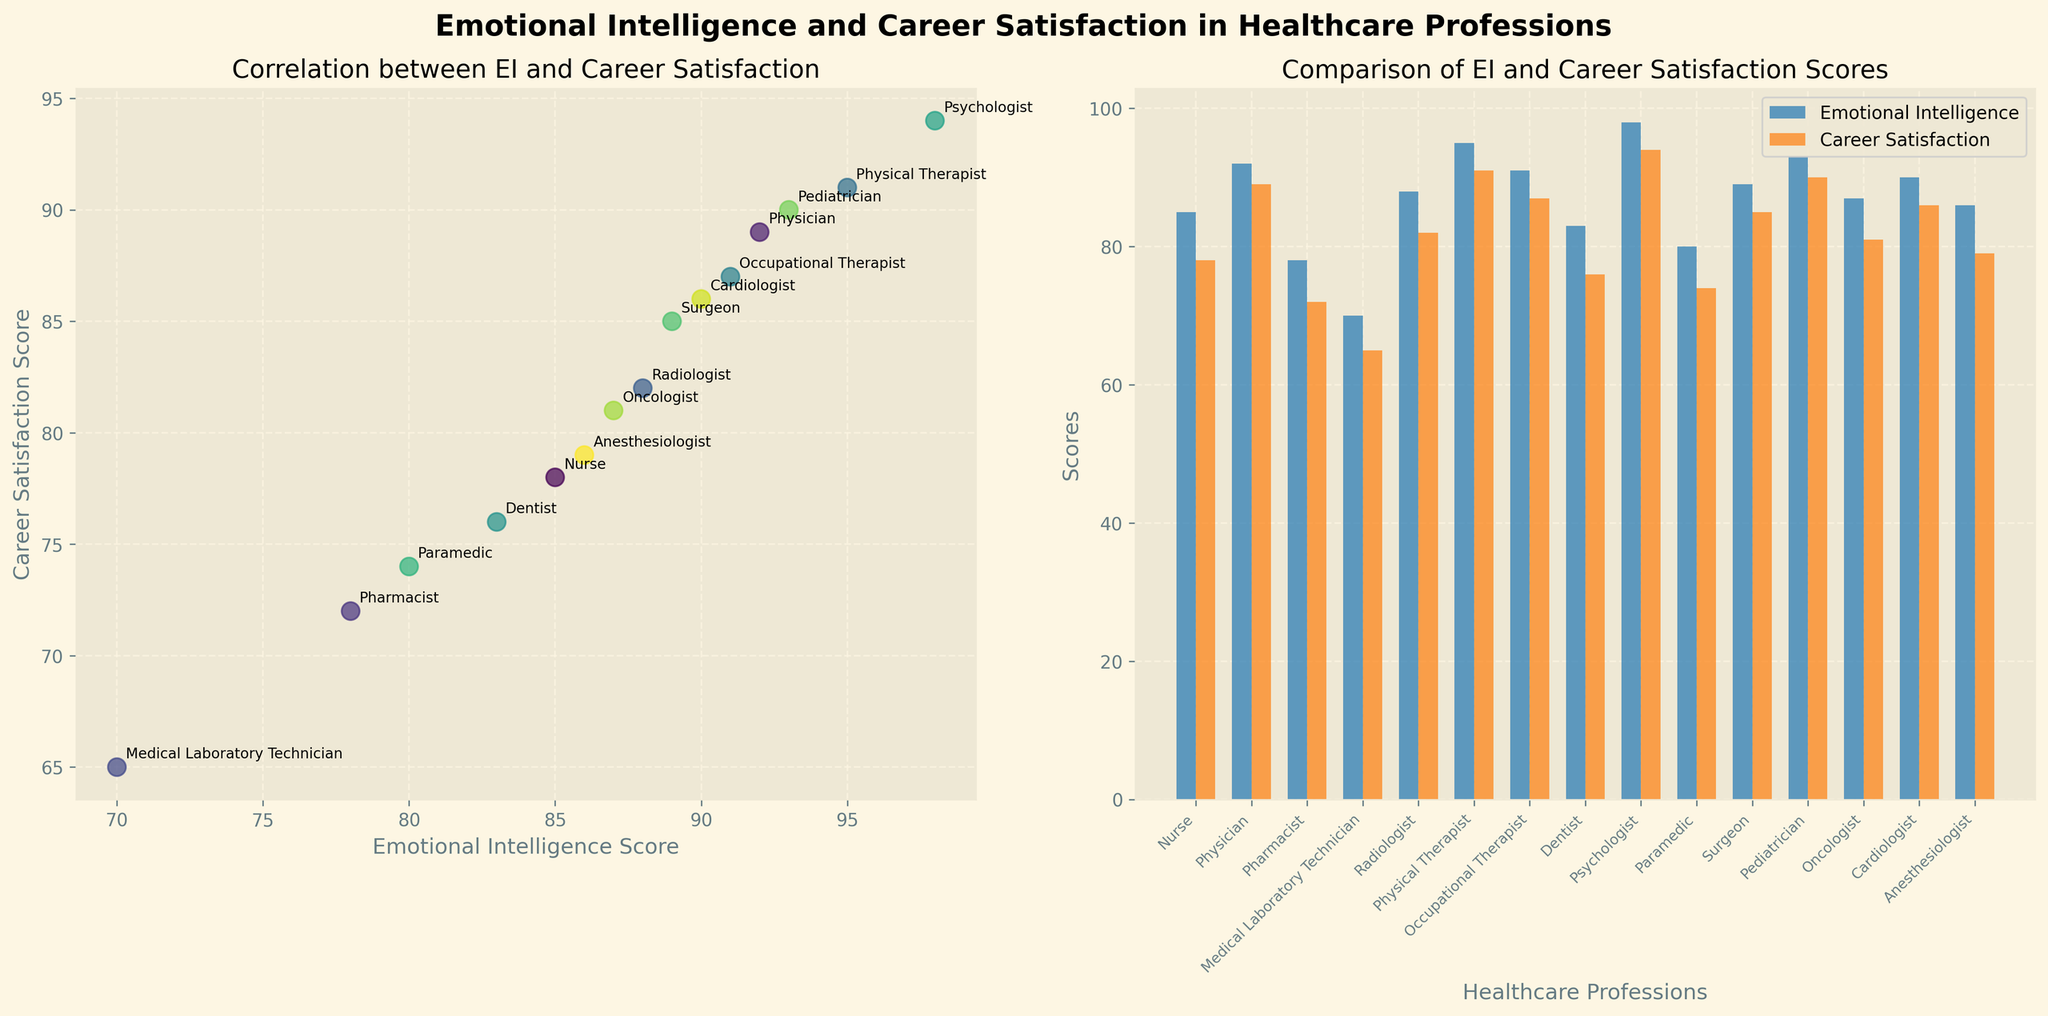What is the title of the figure? The title is located at the top and reads 'Emotional Intelligence and Career Satisfaction in Healthcare Professions'.
Answer: Emotional Intelligence and Career Satisfaction in Healthcare Professions Which healthcare professional has the highest career satisfaction score? By looking at the scatter and bar plots, the psychologist has the highest career satisfaction score of 94.
Answer: Psychologist How many healthcare professions are displayed in the figure? There are 15 bars for both Emotional Intelligence and Career Satisfaction in the bar plot, indicating 15 healthcare professions.
Answer: 15 What are the labels of the x-axes for the scatter and bar plots respectively? The x-axis label of the scatter plot is 'Emotional Intelligence Score', and the x-axis label of the bar plot is 'Healthcare Professions'.
Answer: 'Emotional Intelligence Score', 'Healthcare Professions' Which healthcare professional has both high emotional intelligence and high career satisfaction? In the scatter plot, professionals like Physical Therapists (EI: 95, CS: 91) and Psychologists (EI: 98, CS: 94) fall in the higher range for both scores.
Answer: Physical Therapist and Psychologist What is the emotional intelligence score of the profession with the lowest career satisfaction score? From the bar plot, Medical Laboratory Technician has the lowest career satisfaction score of 65 and their emotional intelligence score is 70.
Answer: 70 What is the average career satisfaction score for the healthcare professions shown? Sum the career satisfaction scores (78+89+72+65+82+91+87+76+94+74+85+90+81+86+79 = 1219) and divide by 15, which gives 1219/15 = 81.3.
Answer: 81.3 Which profession has a higher career satisfaction score than emotional intelligence score? Compare the scores; for example, Dentist has CS: 76 and EI: 83 (76 < 83), others can be visually verified in the scatter plot.
Answer: None (all have EI >= CS) Which professional has the closest emotional intelligence score to that of the Radiologist? The emotional intelligence score of Radiologist is 88. Close scores include 87 (Oncologist) and 89 (Surgeon).
Answer: Surgeon How does the correlation between emotional intelligence scores and career satisfaction scores appear in the scatter plot? The scatter plot shows a positive correlation; as the emotional intelligence score increases, the career satisfaction score tends to increase as well.
Answer: Positive correlation 